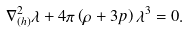<formula> <loc_0><loc_0><loc_500><loc_500>\nabla ^ { 2 } _ { ( h ) } \lambda + 4 \pi \left ( \rho + 3 p \right ) \lambda ^ { 3 } = 0 .</formula> 